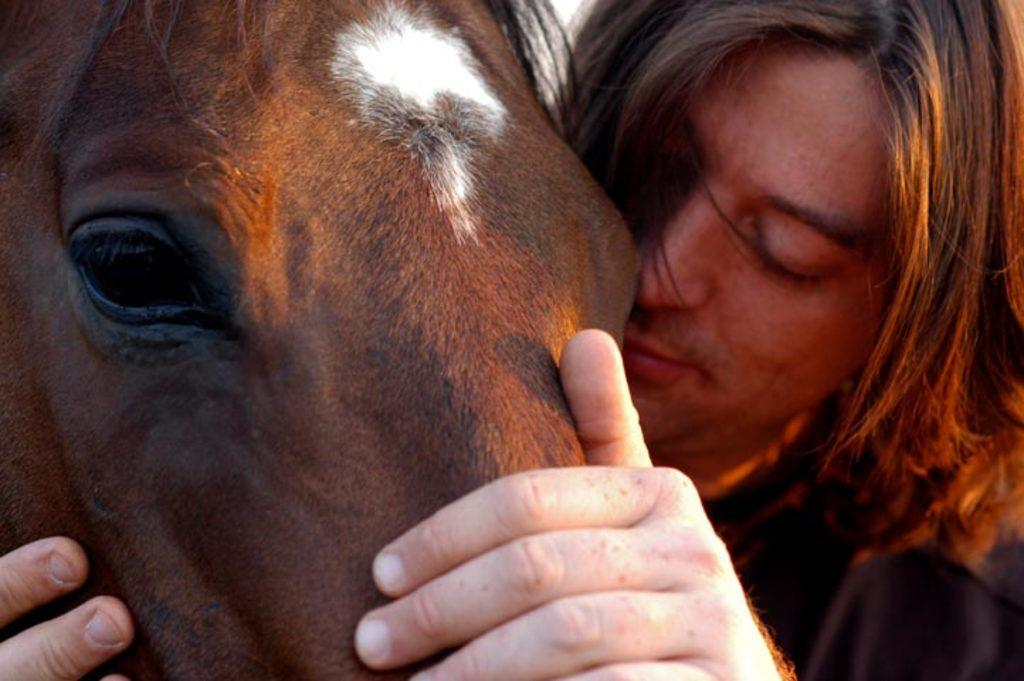What animal is present in the image? There is a horse in the picture. Can you describe any unique features of the horse? The horse has a white mark on its head. Who is in the image with the horse? There is a man in the picture. What is the man doing with the horse? The man is holding the horse. What type of cabbage can be seen growing in the middle of the image? There is no cabbage present in the image; it features a horse and a man. Can you tell me how many books are visible in the library in the image? There is no library present in the image; it features a horse and a man. 